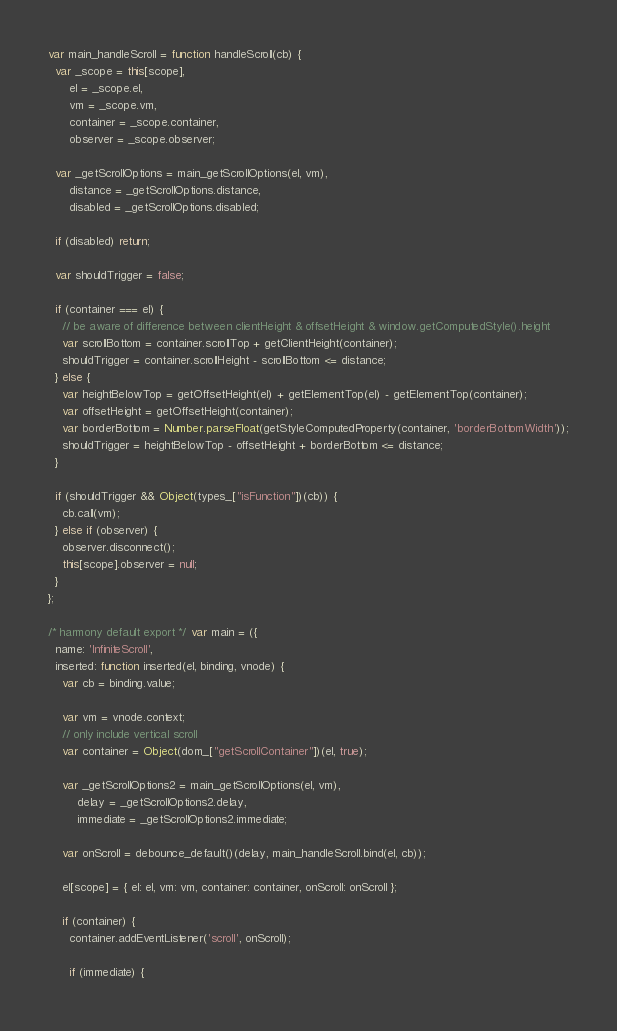<code> <loc_0><loc_0><loc_500><loc_500><_JavaScript_>var main_handleScroll = function handleScroll(cb) {
  var _scope = this[scope],
      el = _scope.el,
      vm = _scope.vm,
      container = _scope.container,
      observer = _scope.observer;

  var _getScrollOptions = main_getScrollOptions(el, vm),
      distance = _getScrollOptions.distance,
      disabled = _getScrollOptions.disabled;

  if (disabled) return;

  var shouldTrigger = false;

  if (container === el) {
    // be aware of difference between clientHeight & offsetHeight & window.getComputedStyle().height
    var scrollBottom = container.scrollTop + getClientHeight(container);
    shouldTrigger = container.scrollHeight - scrollBottom <= distance;
  } else {
    var heightBelowTop = getOffsetHeight(el) + getElementTop(el) - getElementTop(container);
    var offsetHeight = getOffsetHeight(container);
    var borderBottom = Number.parseFloat(getStyleComputedProperty(container, 'borderBottomWidth'));
    shouldTrigger = heightBelowTop - offsetHeight + borderBottom <= distance;
  }

  if (shouldTrigger && Object(types_["isFunction"])(cb)) {
    cb.call(vm);
  } else if (observer) {
    observer.disconnect();
    this[scope].observer = null;
  }
};

/* harmony default export */ var main = ({
  name: 'InfiniteScroll',
  inserted: function inserted(el, binding, vnode) {
    var cb = binding.value;

    var vm = vnode.context;
    // only include vertical scroll
    var container = Object(dom_["getScrollContainer"])(el, true);

    var _getScrollOptions2 = main_getScrollOptions(el, vm),
        delay = _getScrollOptions2.delay,
        immediate = _getScrollOptions2.immediate;

    var onScroll = debounce_default()(delay, main_handleScroll.bind(el, cb));

    el[scope] = { el: el, vm: vm, container: container, onScroll: onScroll };

    if (container) {
      container.addEventListener('scroll', onScroll);

      if (immediate) {</code> 